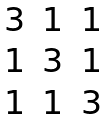Convert formula to latex. <formula><loc_0><loc_0><loc_500><loc_500>\begin{matrix} 3 & 1 & 1 \\ 1 & 3 & 1 \\ 1 & 1 & 3 \end{matrix}</formula> 